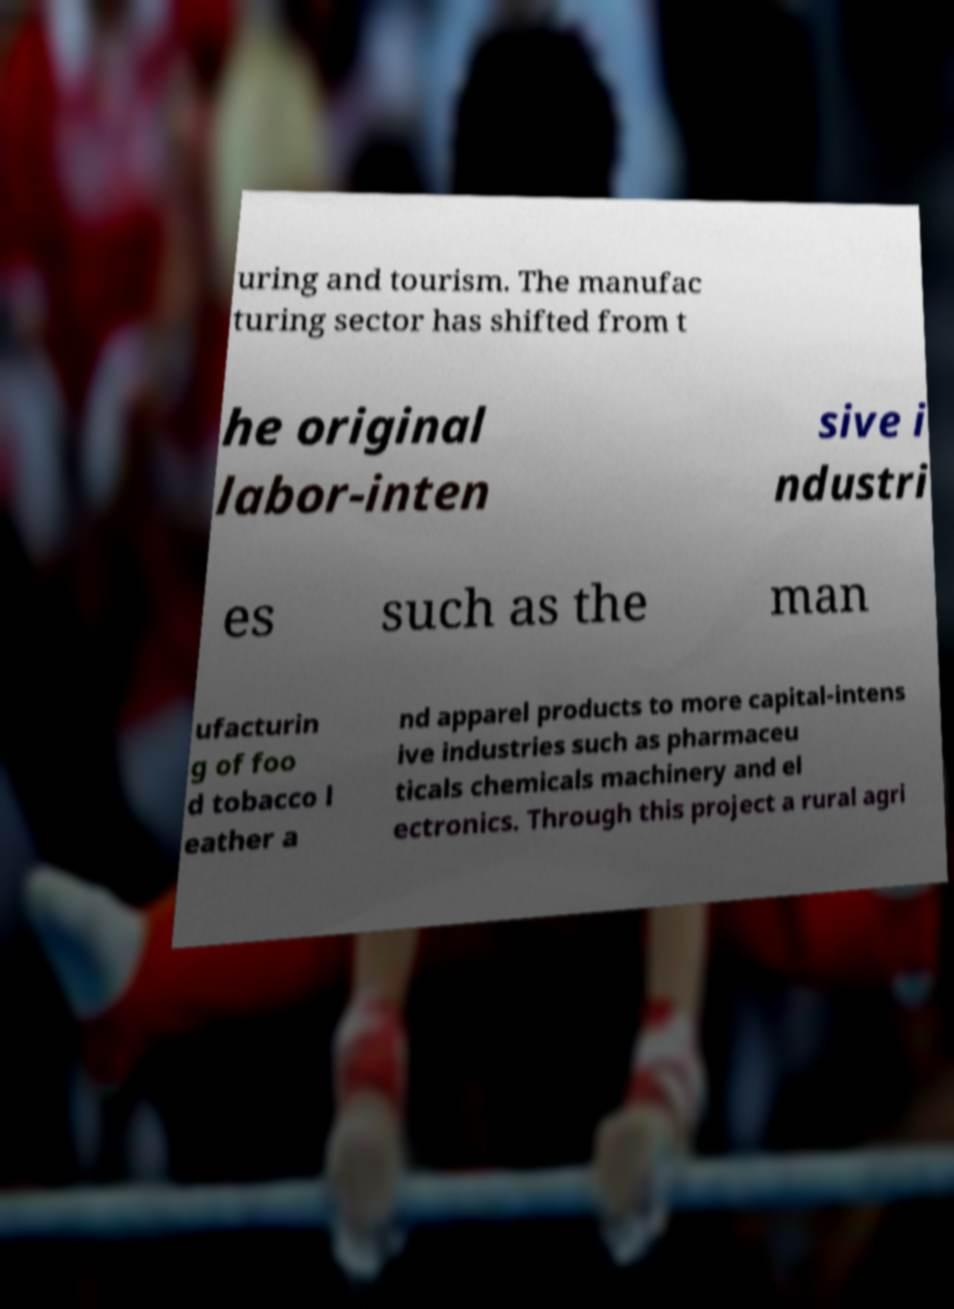Could you extract and type out the text from this image? uring and tourism. The manufac turing sector has shifted from t he original labor-inten sive i ndustri es such as the man ufacturin g of foo d tobacco l eather a nd apparel products to more capital-intens ive industries such as pharmaceu ticals chemicals machinery and el ectronics. Through this project a rural agri 